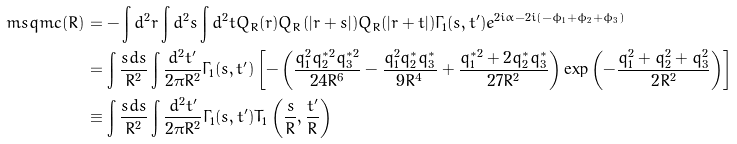<formula> <loc_0><loc_0><loc_500><loc_500>\ m s q m c ( R ) & = - \int d ^ { 2 } r \int d ^ { 2 } s \int d ^ { 2 } t Q _ { R } ( r ) Q _ { R } ( | r + s | ) Q _ { R } ( | r + t | ) \Gamma _ { 1 } ( s , t ^ { \prime } ) e ^ { 2 i \alpha - 2 i ( - \phi _ { 1 } + \phi _ { 2 } + \phi _ { 3 } ) } \\ & = \int \frac { s d s } { R ^ { 2 } } \int \frac { d ^ { 2 } t ^ { \prime } } { 2 \pi R ^ { 2 } } \Gamma _ { 1 } ( s , t ^ { \prime } ) \left [ - \left ( \frac { q _ { 1 } ^ { 2 } q _ { 2 } ^ { * 2 } q _ { 3 } ^ { * 2 } } { 2 4 R ^ { 6 } } - \frac { q _ { 1 } ^ { 2 } q _ { 2 } ^ { * } q _ { 3 } ^ { * } } { 9 R ^ { 4 } } + \frac { q _ { 1 } ^ { * 2 } + 2 q _ { 2 } ^ { * } q _ { 3 } ^ { * } } { 2 7 R ^ { 2 } } \right ) \exp \left ( - \frac { q _ { 1 } ^ { 2 } + q _ { 2 } ^ { 2 } + q _ { 3 } ^ { 2 } } { 2 R ^ { 2 } } \right ) \right ] \\ & \equiv \int \frac { s d s } { R ^ { 2 } } \int \frac { d ^ { 2 } t ^ { \prime } } { 2 \pi R ^ { 2 } } \Gamma _ { 1 } ( s , t ^ { \prime } ) T _ { 1 } \left ( \frac { s } { R } , \frac { t ^ { \prime } } { R } \right )</formula> 